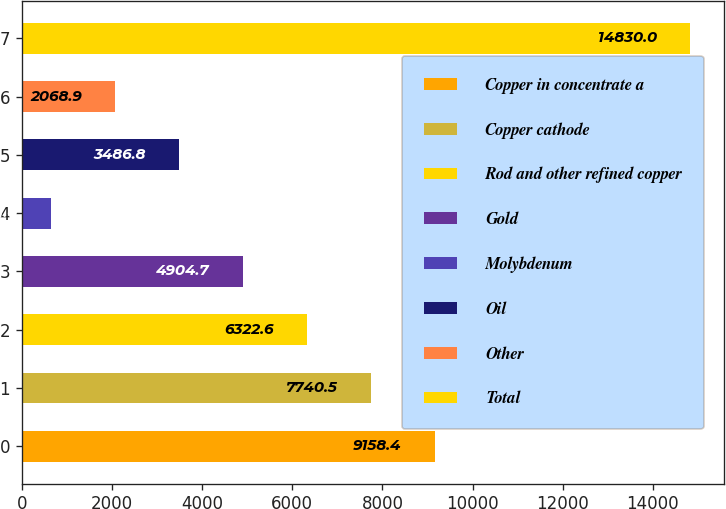<chart> <loc_0><loc_0><loc_500><loc_500><bar_chart><fcel>Copper in concentrate a<fcel>Copper cathode<fcel>Rod and other refined copper<fcel>Gold<fcel>Molybdenum<fcel>Oil<fcel>Other<fcel>Total<nl><fcel>9158.4<fcel>7740.5<fcel>6322.6<fcel>4904.7<fcel>651<fcel>3486.8<fcel>2068.9<fcel>14830<nl></chart> 